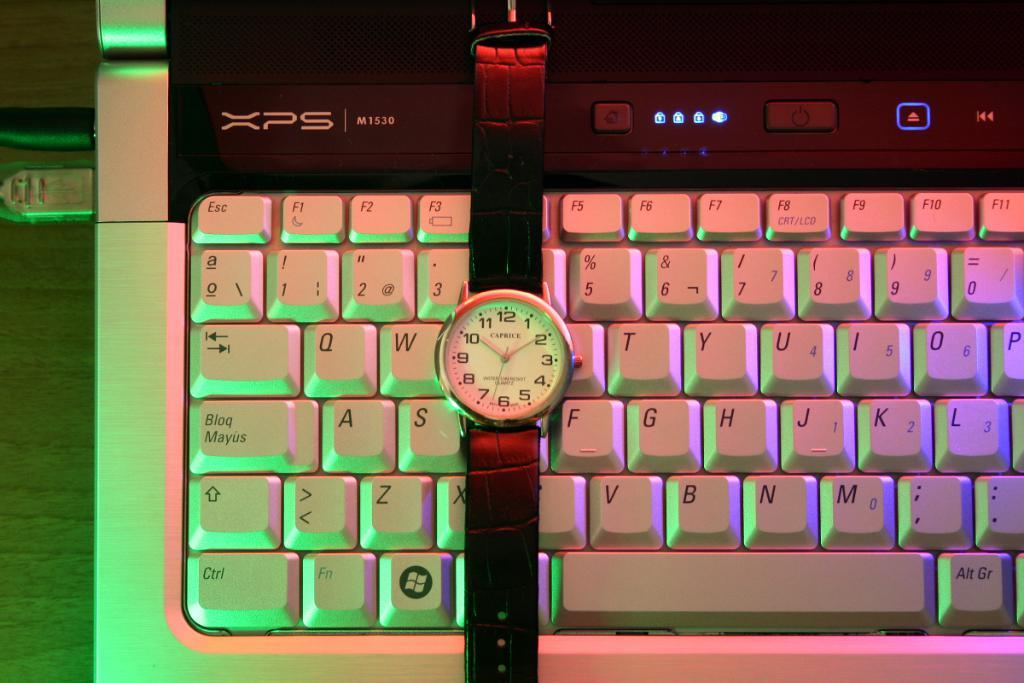<image>
Relay a brief, clear account of the picture shown. A Caprice watch sits on a XPS M1530 laptop 